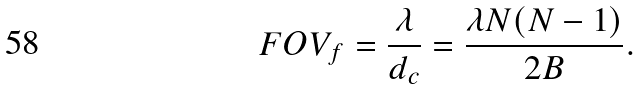Convert formula to latex. <formula><loc_0><loc_0><loc_500><loc_500>F O V _ { f } = \frac { \lambda } { d _ { c } } = \frac { \lambda N ( N - 1 ) } { 2 B } .</formula> 